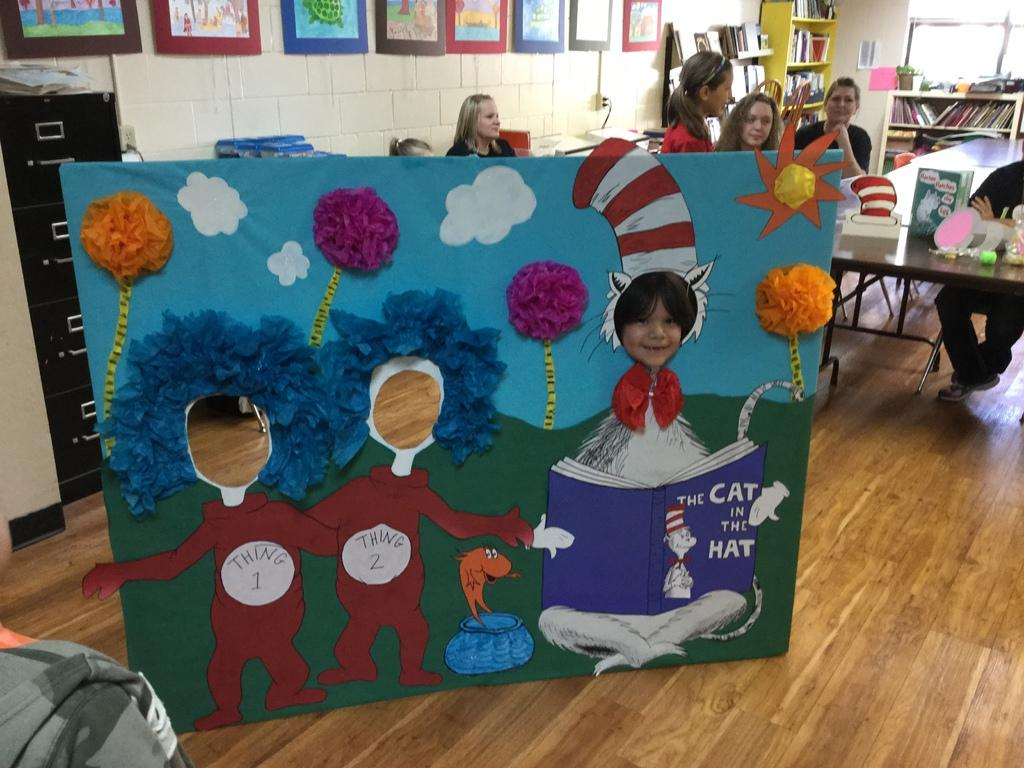<image>
Describe the image concisely. A Cat in the Hat display in a kindergarten classroom where a child is stick his head in the Cat in the hat's face slot. 